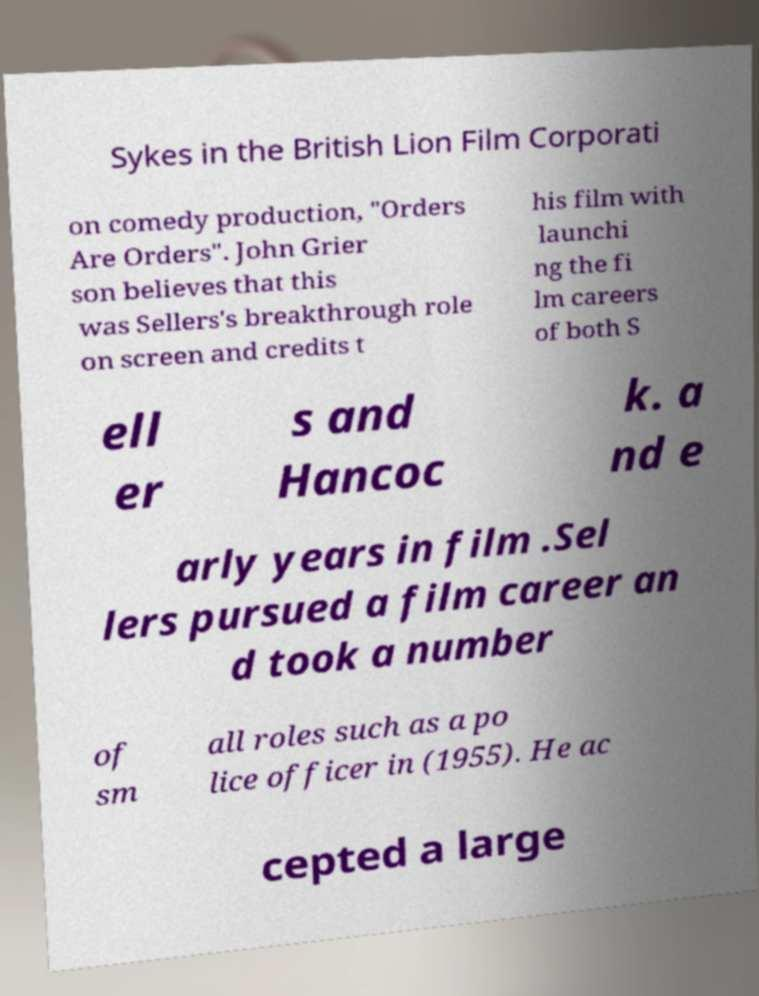Could you assist in decoding the text presented in this image and type it out clearly? Sykes in the British Lion Film Corporati on comedy production, "Orders Are Orders". John Grier son believes that this was Sellers's breakthrough role on screen and credits t his film with launchi ng the fi lm careers of both S ell er s and Hancoc k. a nd e arly years in film .Sel lers pursued a film career an d took a number of sm all roles such as a po lice officer in (1955). He ac cepted a large 